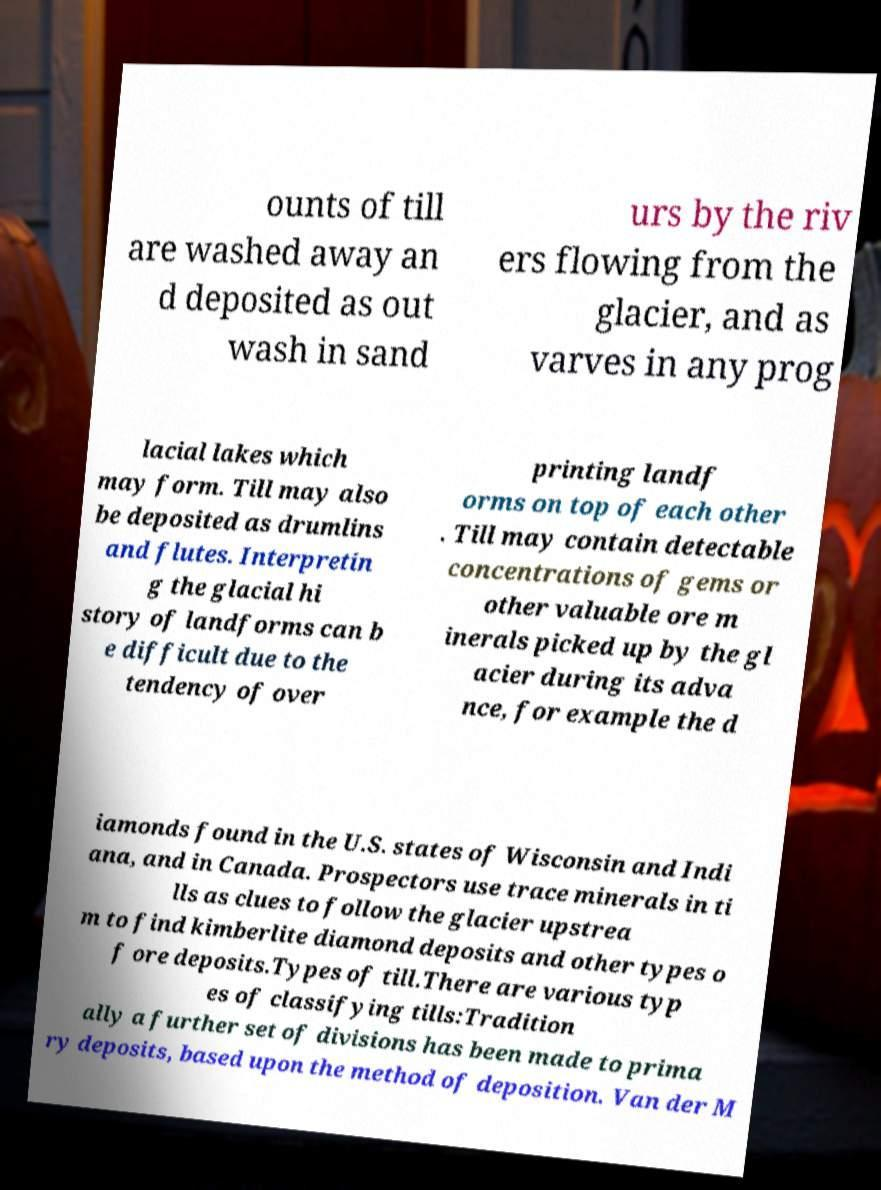Please read and relay the text visible in this image. What does it say? ounts of till are washed away an d deposited as out wash in sand urs by the riv ers flowing from the glacier, and as varves in any prog lacial lakes which may form. Till may also be deposited as drumlins and flutes. Interpretin g the glacial hi story of landforms can b e difficult due to the tendency of over printing landf orms on top of each other . Till may contain detectable concentrations of gems or other valuable ore m inerals picked up by the gl acier during its adva nce, for example the d iamonds found in the U.S. states of Wisconsin and Indi ana, and in Canada. Prospectors use trace minerals in ti lls as clues to follow the glacier upstrea m to find kimberlite diamond deposits and other types o f ore deposits.Types of till.There are various typ es of classifying tills:Tradition ally a further set of divisions has been made to prima ry deposits, based upon the method of deposition. Van der M 